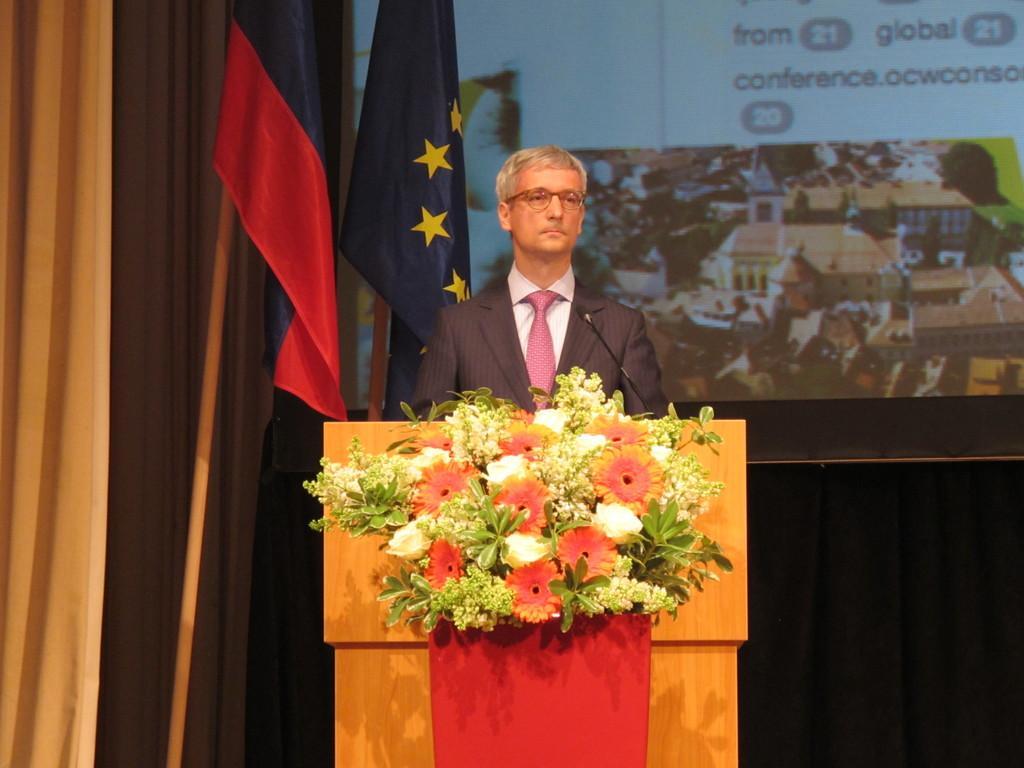How would you summarize this image in a sentence or two? In this image I can see the person standing in-front of the podium. The person is wearing the blazer, shirt and tie. There is a mic on the podium. I can also see the decorative flowers to the podium. The flowers are in red and white color. In the back I can see two flags and also the screen. To the left there is a curtain. 